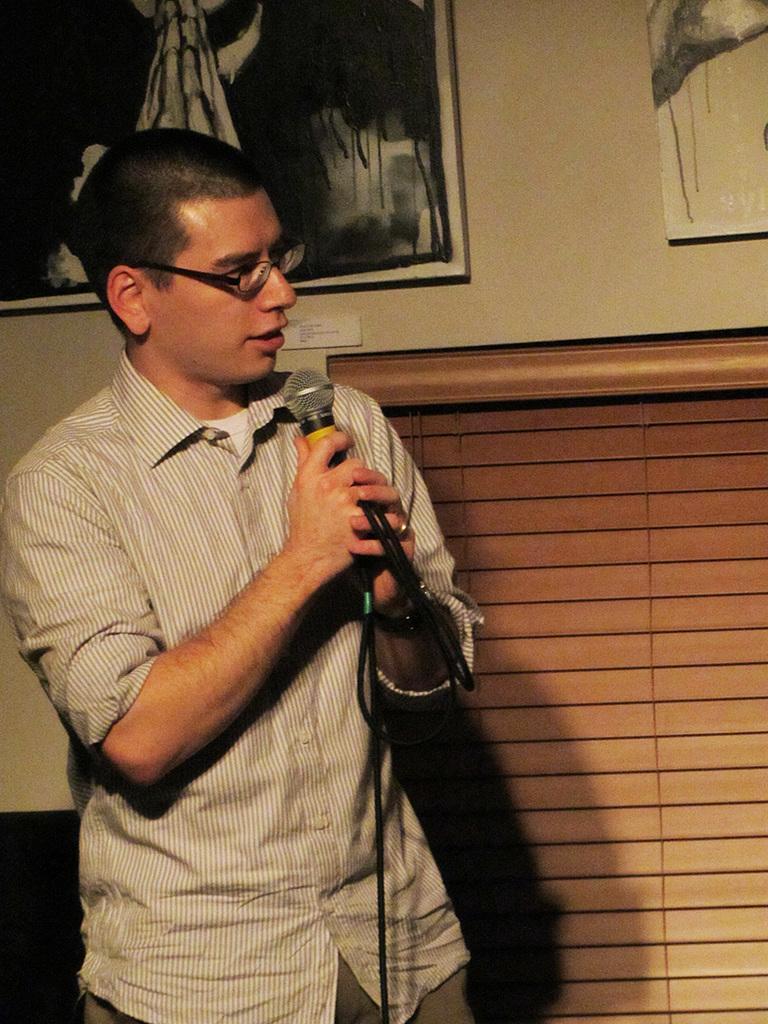Could you give a brief overview of what you see in this image? In this image we can see there is a person standing and holding a microphone. At the back there is a black color object. And there are window strips. There are photo frames attached to the wall. 